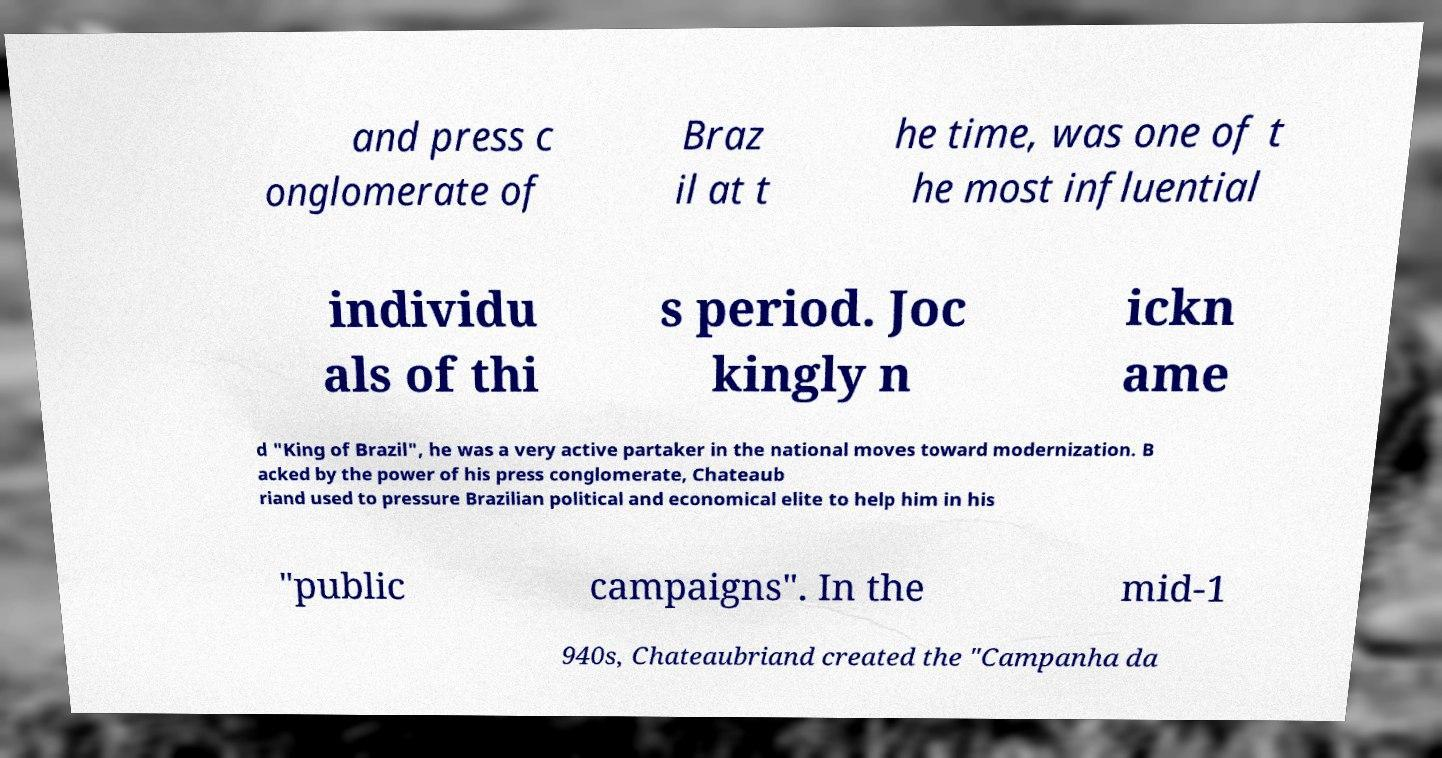Can you read and provide the text displayed in the image?This photo seems to have some interesting text. Can you extract and type it out for me? and press c onglomerate of Braz il at t he time, was one of t he most influential individu als of thi s period. Joc kingly n ickn ame d "King of Brazil", he was a very active partaker in the national moves toward modernization. B acked by the power of his press conglomerate, Chateaub riand used to pressure Brazilian political and economical elite to help him in his "public campaigns". In the mid-1 940s, Chateaubriand created the "Campanha da 